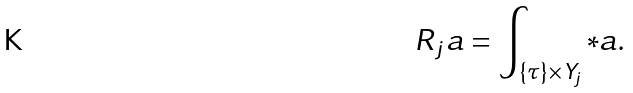<formula> <loc_0><loc_0><loc_500><loc_500>R _ { j } a = \int _ { \{ \tau \} \times Y _ { j } } * a .</formula> 